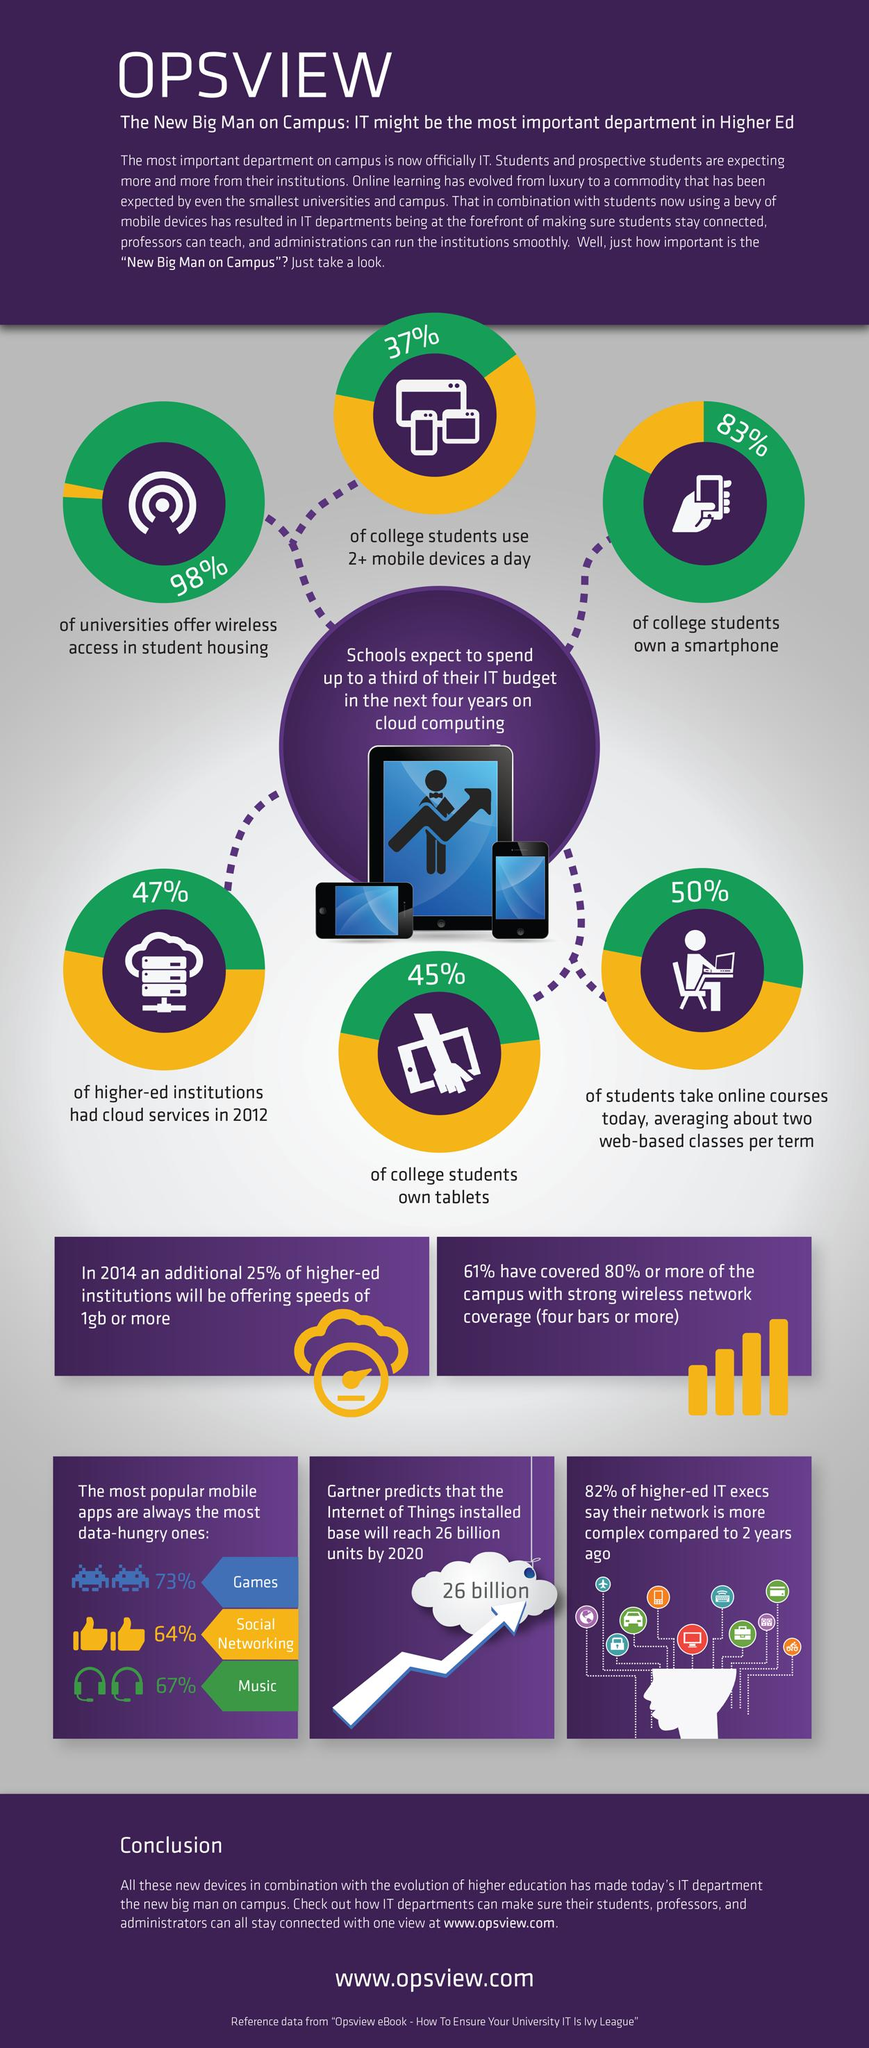Outline some significant characteristics in this image. A recent study revealed that only 17% of college students do not own a smartphone. According to a recent survey, a significant percentage of students do not own tablets. Specifically, 55% of students do not own tablets. According to a recent survey, 63% of students do not use more than two mobile devices per day. The average percentage of users using games, social media, and music apps is 68%. In 2012, approximately 53% of institutions did not have cloud services. 